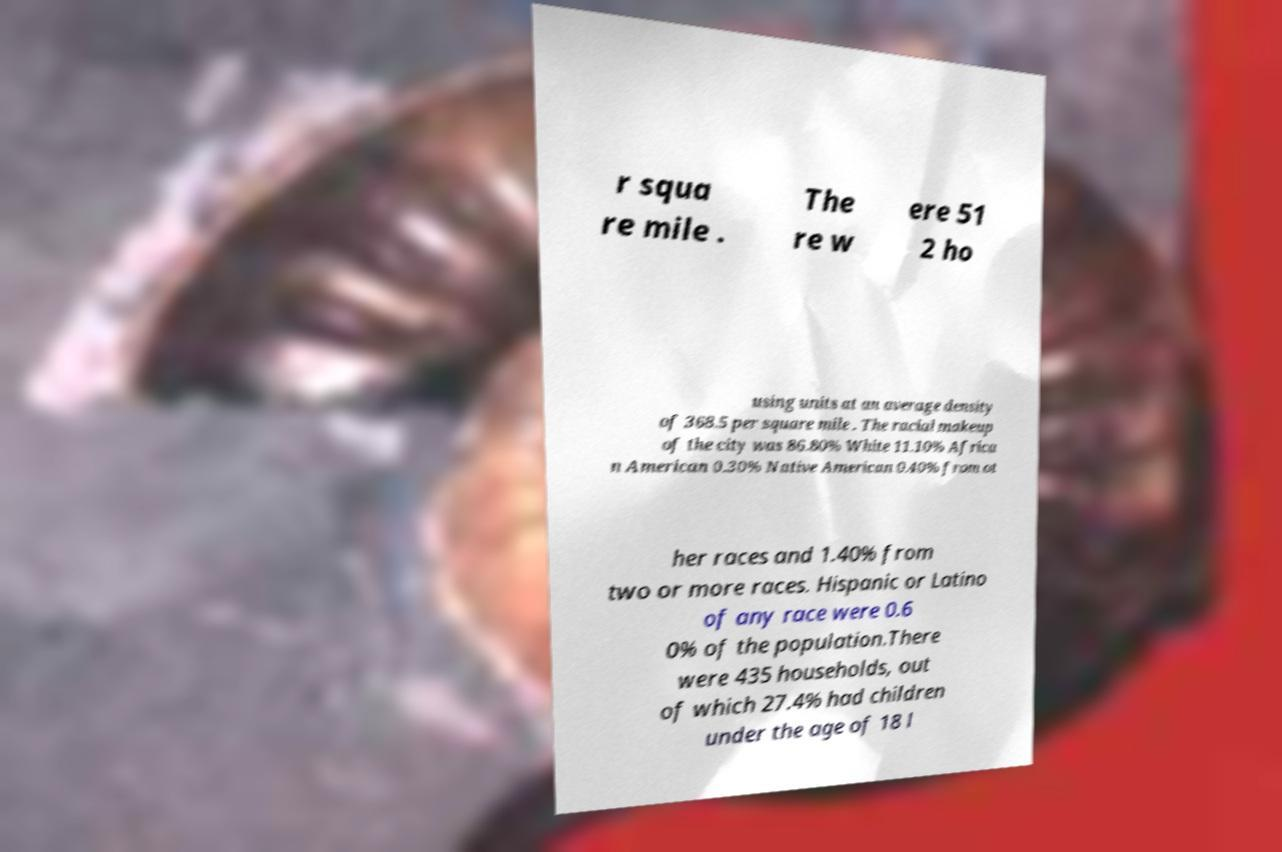Could you extract and type out the text from this image? r squa re mile . The re w ere 51 2 ho using units at an average density of 368.5 per square mile . The racial makeup of the city was 86.80% White 11.10% Africa n American 0.30% Native American 0.40% from ot her races and 1.40% from two or more races. Hispanic or Latino of any race were 0.6 0% of the population.There were 435 households, out of which 27.4% had children under the age of 18 l 